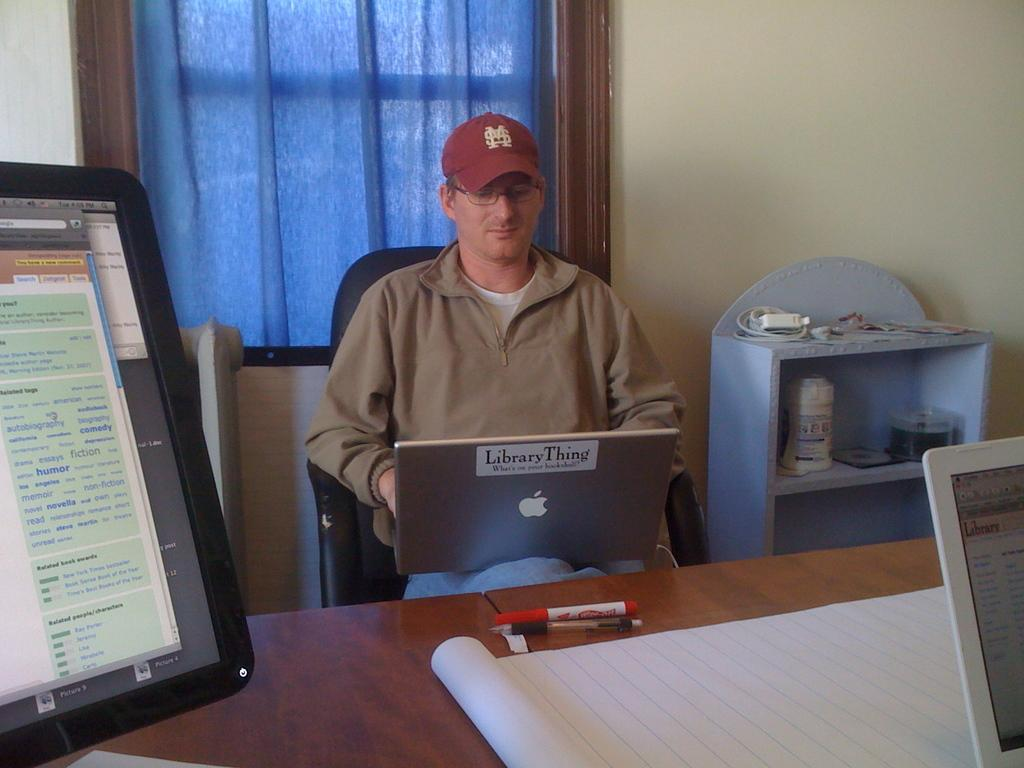<image>
Write a terse but informative summary of the picture. A man in a red hat and park sits with a silver apple laptop on his lap. 